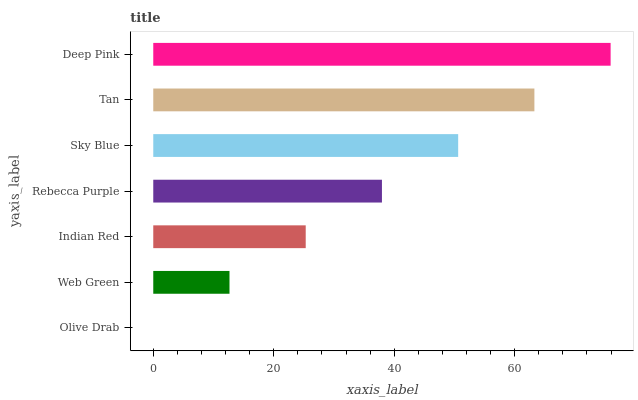Is Olive Drab the minimum?
Answer yes or no. Yes. Is Deep Pink the maximum?
Answer yes or no. Yes. Is Web Green the minimum?
Answer yes or no. No. Is Web Green the maximum?
Answer yes or no. No. Is Web Green greater than Olive Drab?
Answer yes or no. Yes. Is Olive Drab less than Web Green?
Answer yes or no. Yes. Is Olive Drab greater than Web Green?
Answer yes or no. No. Is Web Green less than Olive Drab?
Answer yes or no. No. Is Rebecca Purple the high median?
Answer yes or no. Yes. Is Rebecca Purple the low median?
Answer yes or no. Yes. Is Olive Drab the high median?
Answer yes or no. No. Is Tan the low median?
Answer yes or no. No. 